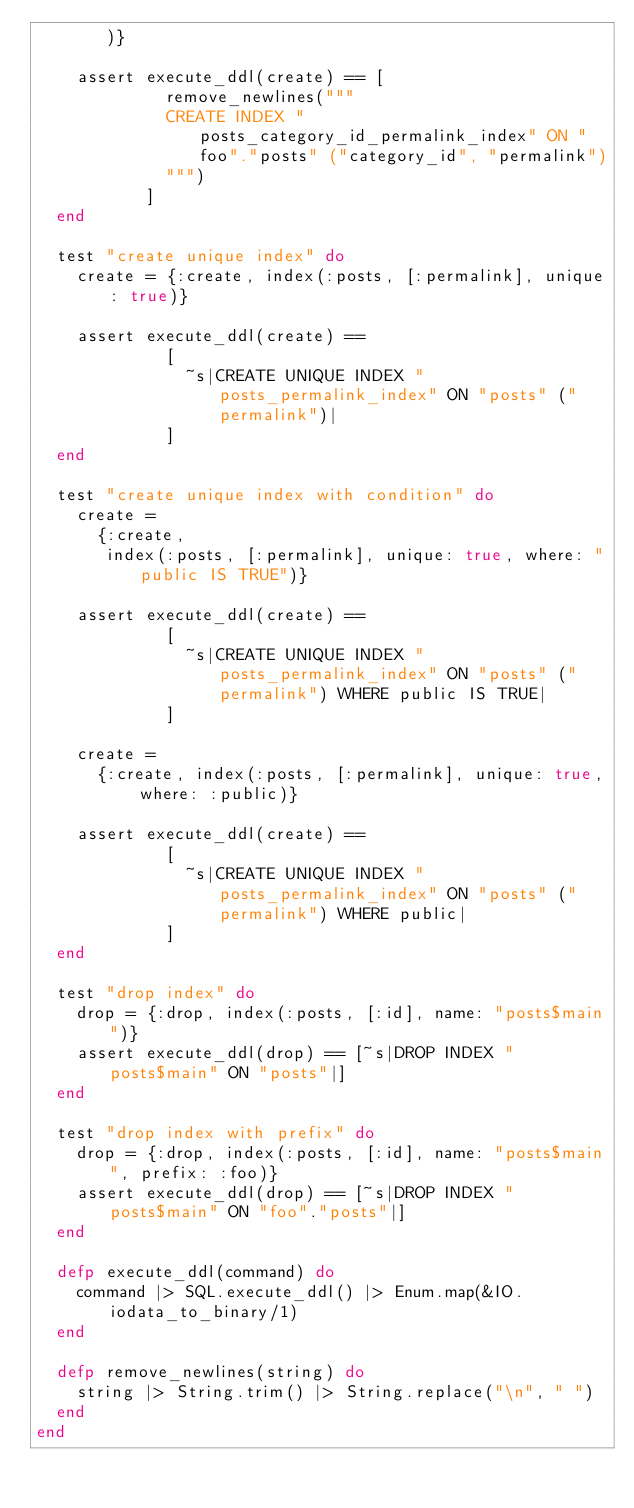Convert code to text. <code><loc_0><loc_0><loc_500><loc_500><_Elixir_>       )}

    assert execute_ddl(create) == [
             remove_newlines("""
             CREATE INDEX "posts_category_id_permalink_index" ON "foo"."posts" ("category_id", "permalink")
             """)
           ]
  end

  test "create unique index" do
    create = {:create, index(:posts, [:permalink], unique: true)}

    assert execute_ddl(create) ==
             [
               ~s|CREATE UNIQUE INDEX "posts_permalink_index" ON "posts" ("permalink")|
             ]
  end

  test "create unique index with condition" do
    create =
      {:create,
       index(:posts, [:permalink], unique: true, where: "public IS TRUE")}

    assert execute_ddl(create) ==
             [
               ~s|CREATE UNIQUE INDEX "posts_permalink_index" ON "posts" ("permalink") WHERE public IS TRUE|
             ]

    create =
      {:create, index(:posts, [:permalink], unique: true, where: :public)}

    assert execute_ddl(create) ==
             [
               ~s|CREATE UNIQUE INDEX "posts_permalink_index" ON "posts" ("permalink") WHERE public|
             ]
  end

  test "drop index" do
    drop = {:drop, index(:posts, [:id], name: "posts$main")}
    assert execute_ddl(drop) == [~s|DROP INDEX "posts$main" ON "posts"|]
  end

  test "drop index with prefix" do
    drop = {:drop, index(:posts, [:id], name: "posts$main", prefix: :foo)}
    assert execute_ddl(drop) == [~s|DROP INDEX "posts$main" ON "foo"."posts"|]
  end

  defp execute_ddl(command) do
    command |> SQL.execute_ddl() |> Enum.map(&IO.iodata_to_binary/1)
  end

  defp remove_newlines(string) do
    string |> String.trim() |> String.replace("\n", " ")
  end
end
</code> 